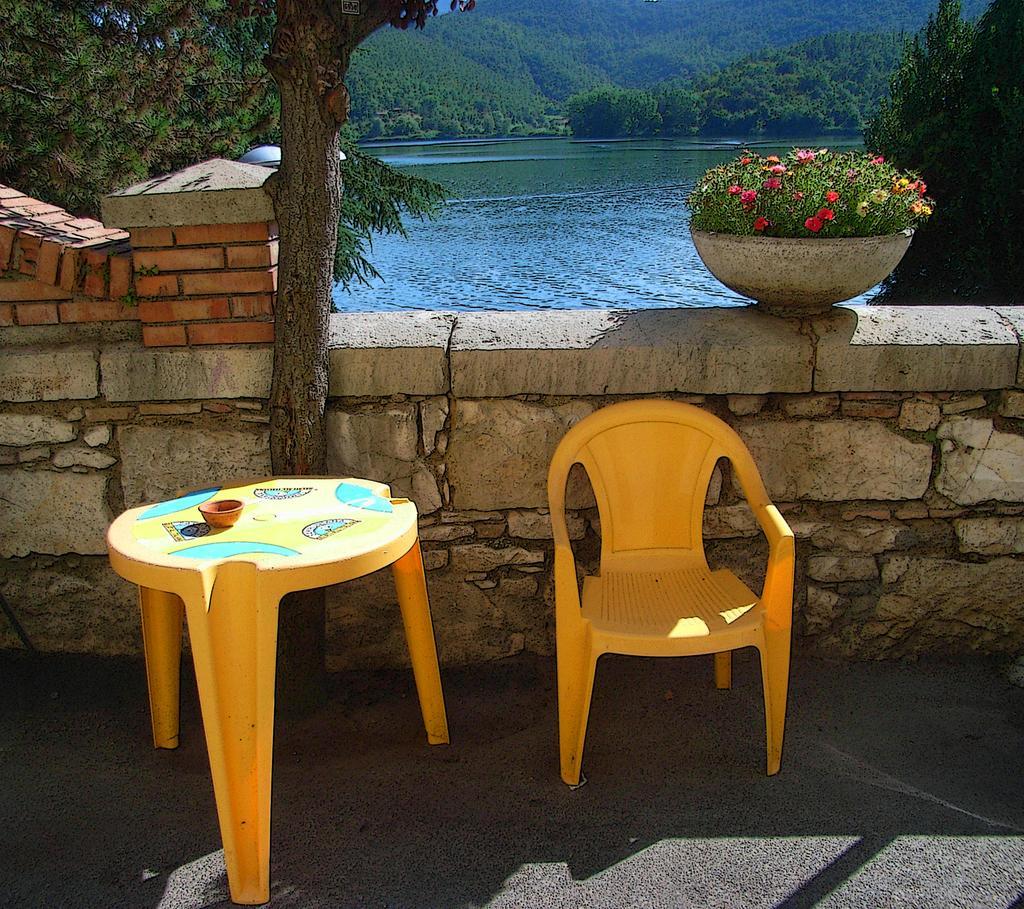Please provide a concise description of this image. Here we have chair, table, both are yellow in color and on the table we have some bowl and these are placed on road. Here we have wall. behind it we have river or lake and also we have mountain. On the wall we have flower pot and in the background we have trees to the left and right. 